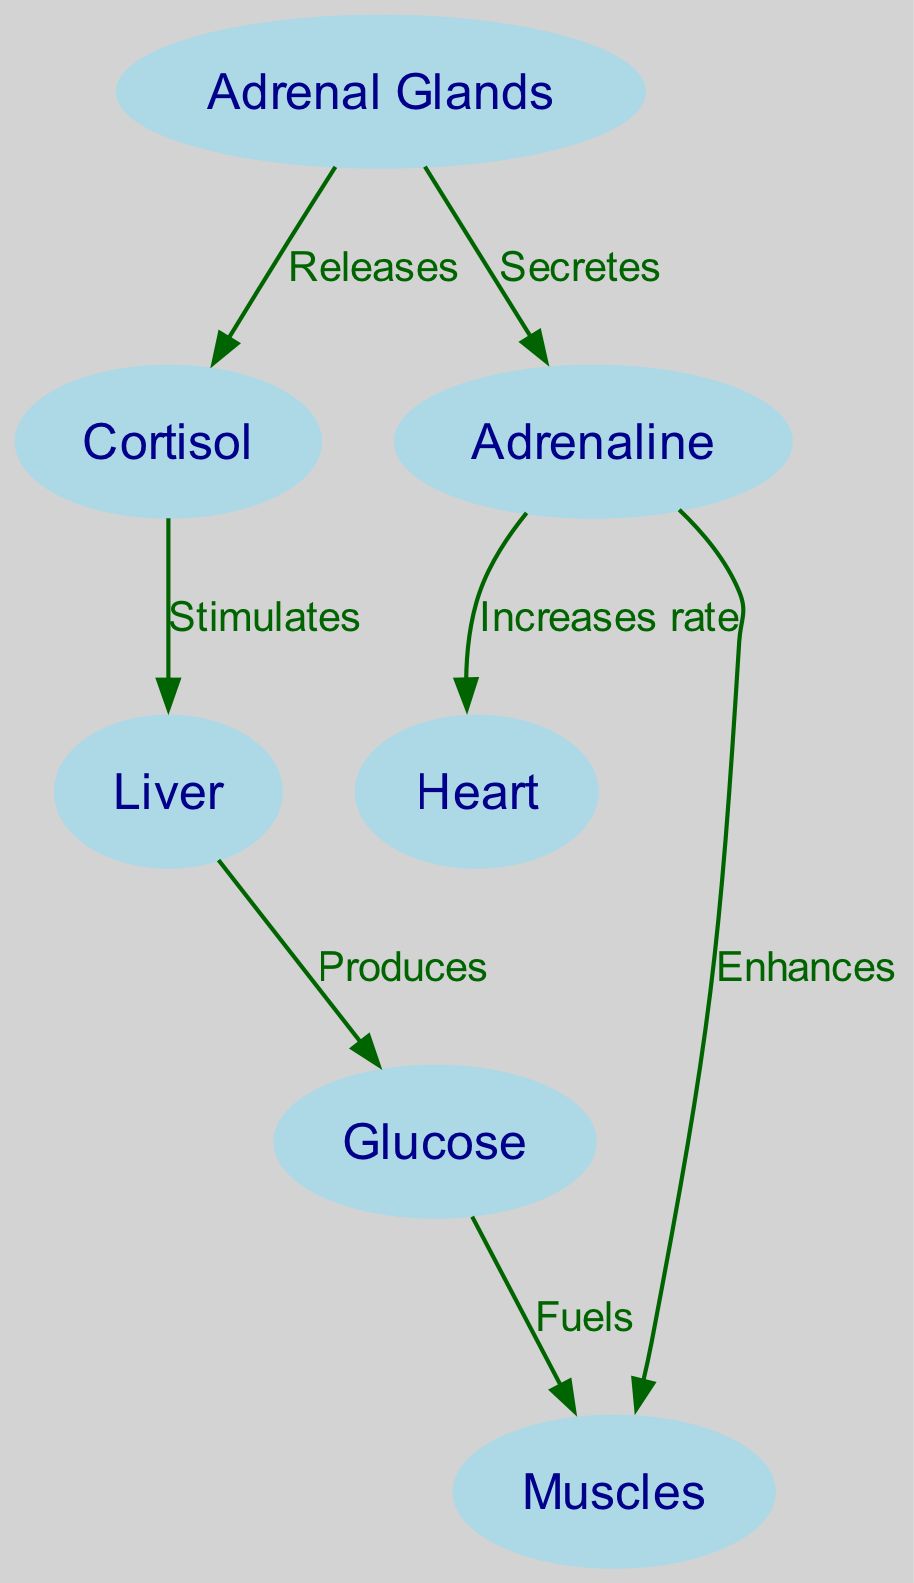What is the total number of nodes in the diagram? The diagram contains 7 distinct entities, which represent parts of the metabolic process involved in responding to stress. These entities are the Adrenal Glands, Cortisol, Adrenaline, Liver, Glucose, Heart, and Muscles.
Answer: 7 Which hormone do the adrenal glands release? According to the diagram, the Adrenal Glands release Cortisol as indicated by the edge labeled "Releases" that connects node 1 to node 2.
Answer: Cortisol What does adrenaline enhance in the body? The diagram shows that Adrenaline enhances Muscles, as indicated by the connection labeled "Enhances" from node 3 to node 7.
Answer: Muscles How does cortisol affect the liver? The diagram illustrates that Cortisol stimulates the Liver, depicted by the “Stimulates” edge from node 2 to node 4.
Answer: Stimulates What substance do the muscles get fueled by? The flow in the diagram indicates that Muscles are fueled by Glucose, as shown by the directed edge labeled "Fuels" from node 5 to node 7.
Answer: Glucose What is the relationship between adrenaline and heart rate? The diagram reveals that Adrenaline increases the rate of the Heart, as represented by the edge labeled "Increases rate" from node 3 to node 6.
Answer: Increases rate How many edges are present in the diagram? Upon examining the connections between the nodes, there are a total of 6 directed edges illustrating the relationships between various components.
Answer: 6 Which organ produces glucose in response to cortisol stimulation? The diagram clearly states that the Liver produces Glucose when stimulated by Cortisol, as indicated by the edge labeled "Produces" from node 4 to node 5.
Answer: Liver 